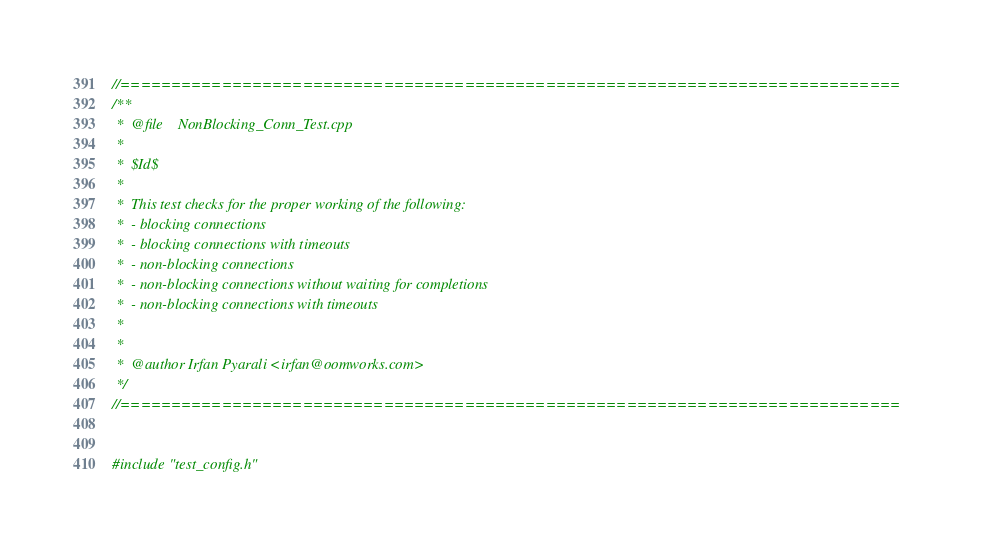Convert code to text. <code><loc_0><loc_0><loc_500><loc_500><_C++_>
//=============================================================================
/**
 *  @file    NonBlocking_Conn_Test.cpp
 *
 *  $Id$
 *
 *  This test checks for the proper working of the following:
 *  - blocking connections
 *  - blocking connections with timeouts
 *  - non-blocking connections
 *  - non-blocking connections without waiting for completions
 *  - non-blocking connections with timeouts
 *
 *
 *  @author Irfan Pyarali <irfan@oomworks.com>
 */
//=============================================================================


#include "test_config.h"</code> 